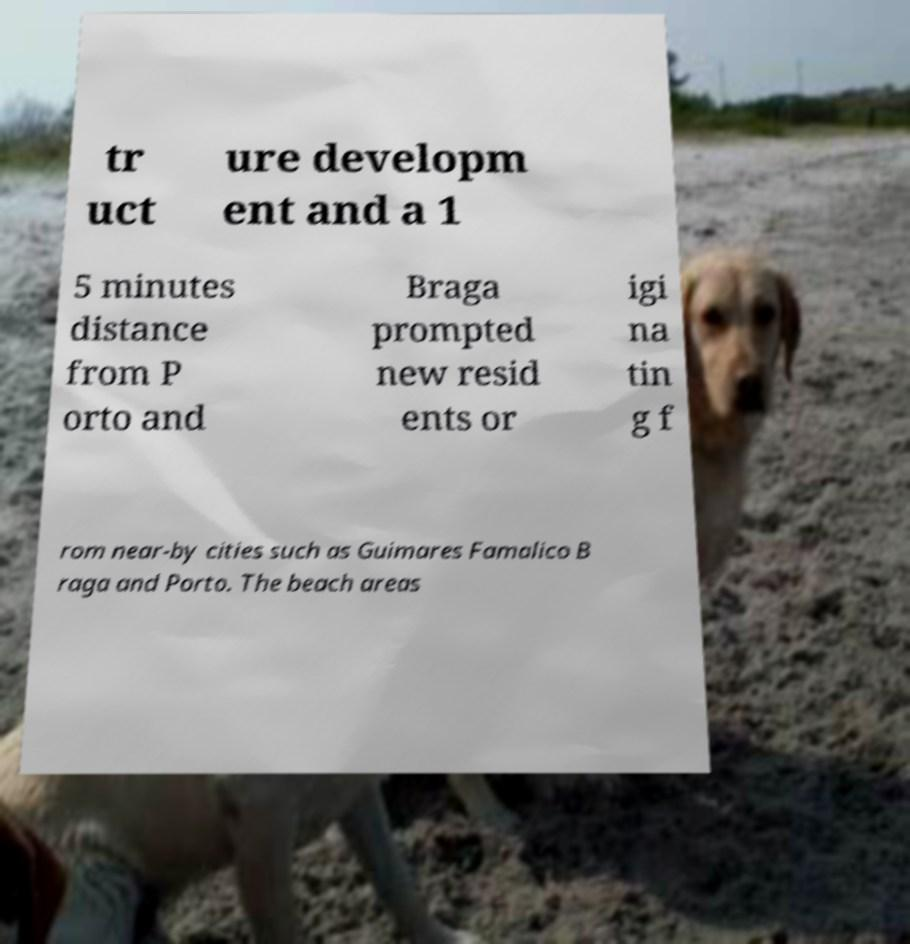Could you extract and type out the text from this image? tr uct ure developm ent and a 1 5 minutes distance from P orto and Braga prompted new resid ents or igi na tin g f rom near-by cities such as Guimares Famalico B raga and Porto. The beach areas 